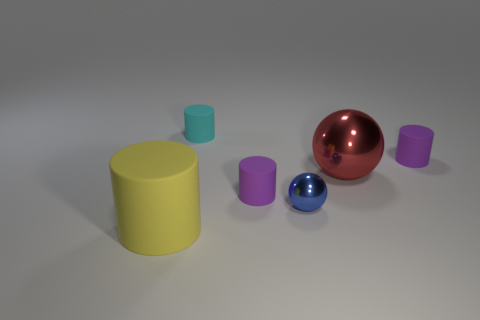Add 2 large yellow matte cylinders. How many objects exist? 8 Subtract all big yellow matte cylinders. How many cylinders are left? 3 Subtract all yellow cylinders. How many cylinders are left? 3 Subtract 2 spheres. How many spheres are left? 0 Subtract all cylinders. How many objects are left? 2 Subtract all gray balls. How many yellow cylinders are left? 1 Subtract all tiny rubber objects. Subtract all cyan objects. How many objects are left? 2 Add 3 big matte cylinders. How many big matte cylinders are left? 4 Add 4 small blue metallic objects. How many small blue metallic objects exist? 5 Subtract 0 cyan cubes. How many objects are left? 6 